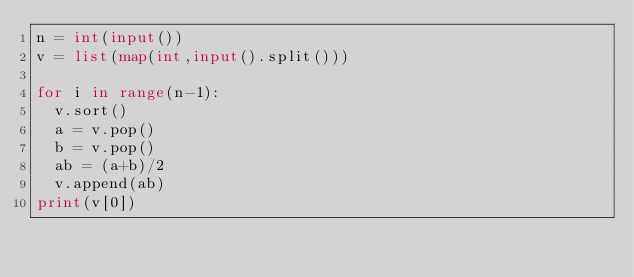<code> <loc_0><loc_0><loc_500><loc_500><_Python_>n = int(input())
v = list(map(int,input().split()))

for i in range(n-1):
	v.sort()
	a = v.pop()
	b = v.pop()
	ab = (a+b)/2
	v.append(ab)
print(v[0])</code> 